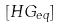<formula> <loc_0><loc_0><loc_500><loc_500>[ H G _ { e q } ]</formula> 